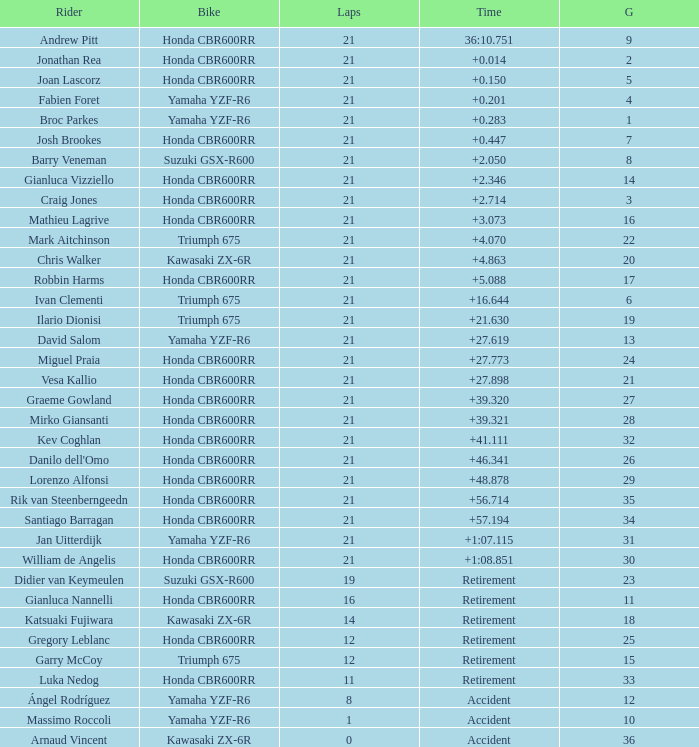What is the maximum number of laps run by ilario dionisi? 21.0. 